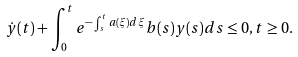Convert formula to latex. <formula><loc_0><loc_0><loc_500><loc_500>\dot { y } ( t ) + \int _ { 0 } ^ { t } e ^ { - \int _ { s } ^ { t } a ( \xi ) d \xi } b ( s ) y ( s ) d s \leq 0 , t \geq 0 .</formula> 